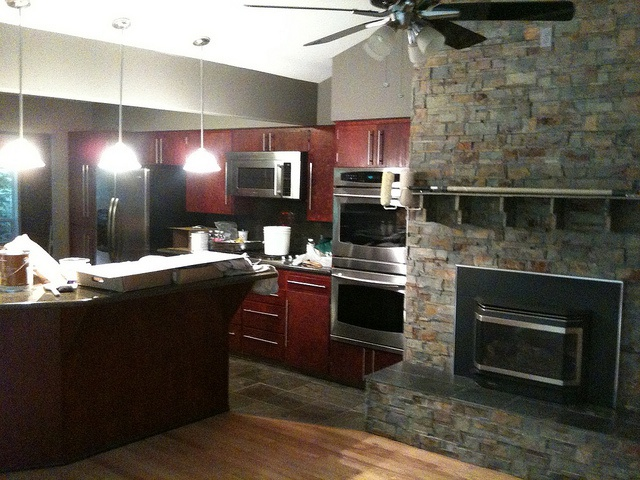Describe the objects in this image and their specific colors. I can see oven in white, black, gray, and darkgray tones, refrigerator in white, gray, black, and darkgray tones, microwave in white, black, gray, and darkgray tones, refrigerator in white, black, gray, and purple tones, and bowl in white, tan, and gray tones in this image. 